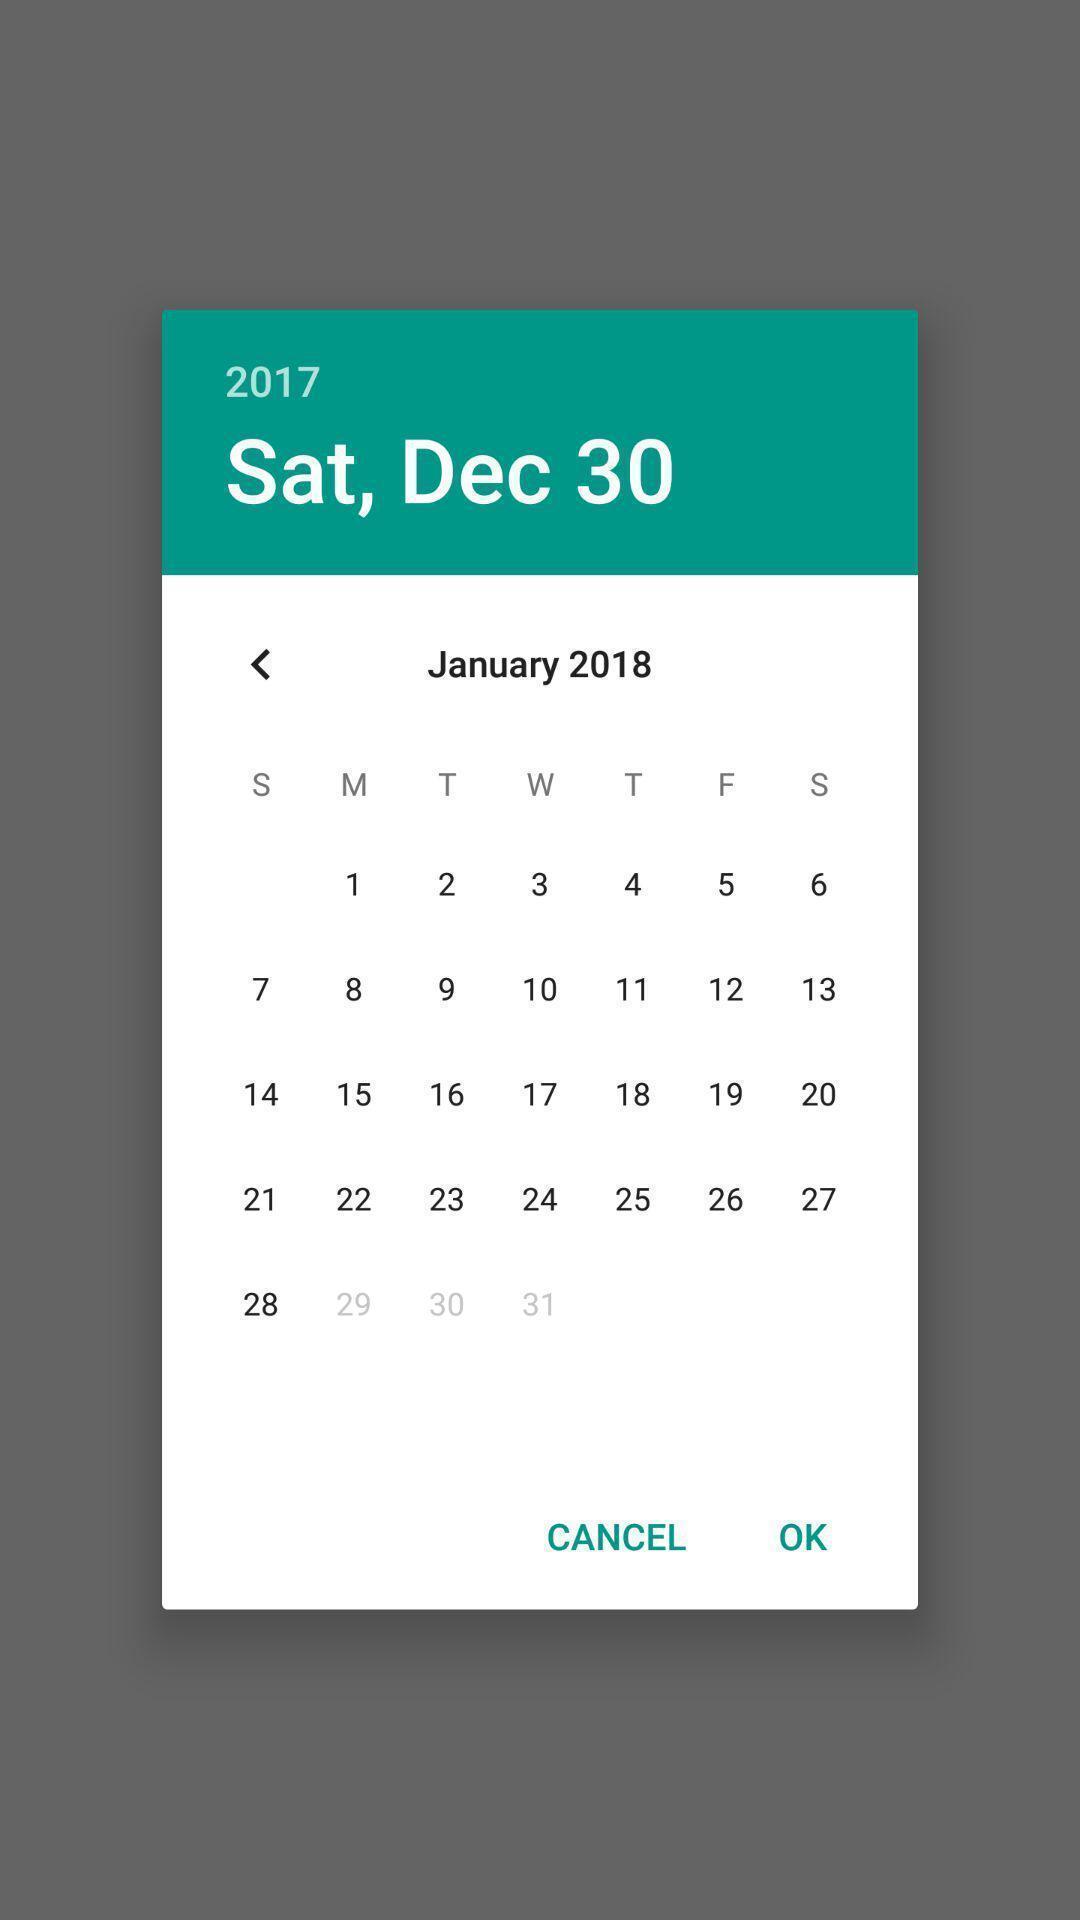Please provide a description for this image. Pop-up screen displaying with calendar to set date. 